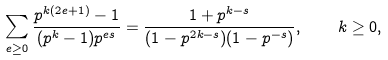Convert formula to latex. <formula><loc_0><loc_0><loc_500><loc_500>\sum _ { e \geq 0 } \frac { p ^ { k ( 2 e + 1 ) } - 1 } { ( p ^ { k } - 1 ) p ^ { e s } } = \frac { 1 + p ^ { k - s } } { ( 1 - p ^ { 2 k - s } ) ( 1 - p ^ { - s } ) } , \quad k \geq 0 ,</formula> 